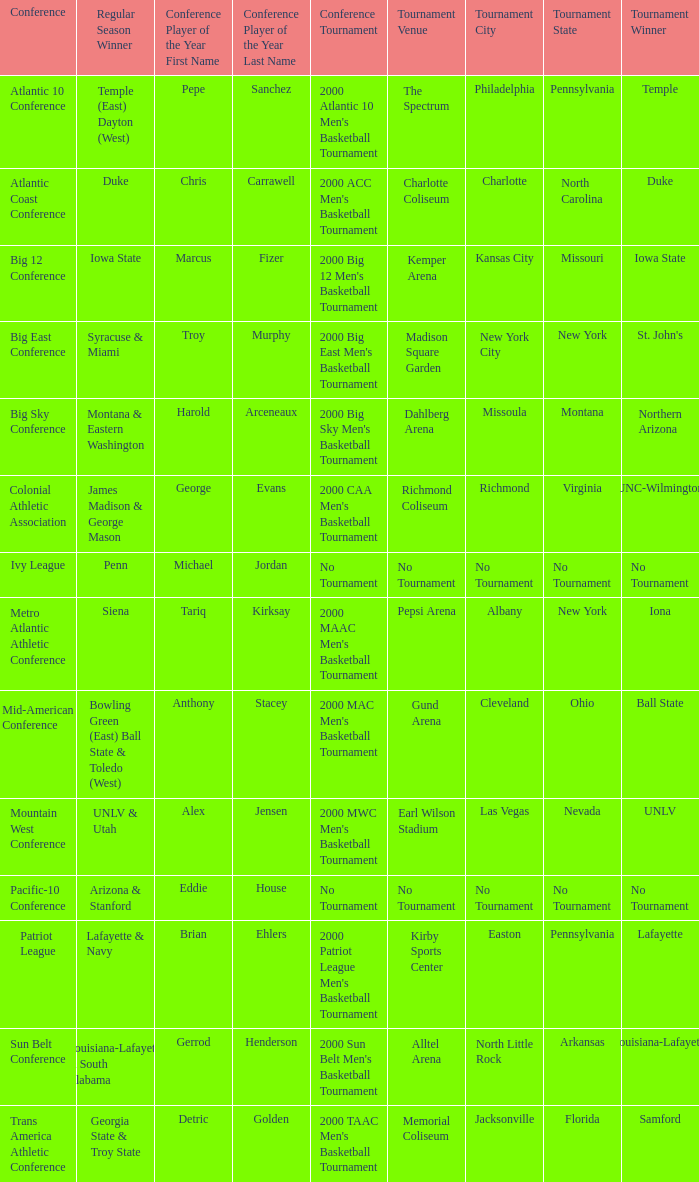How many players of the year are there in the Mountain West Conference? 1.0. 